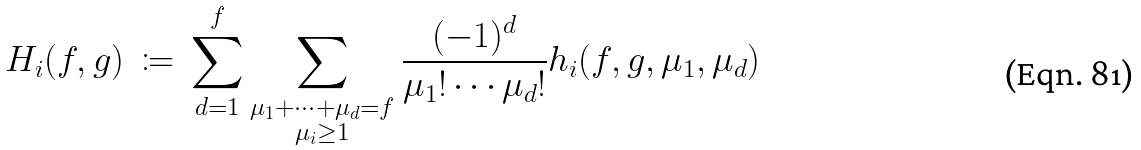<formula> <loc_0><loc_0><loc_500><loc_500>H _ { i } ( f , g ) \ \coloneqq \ \sum _ { d = 1 } ^ { f } \sum _ { \substack { \mu _ { 1 } + \dots + \mu _ { d } = f \\ \mu _ { i } \geq 1 } } \frac { ( - 1 ) ^ { d } } { \mu _ { 1 } ! \cdots \mu _ { d } ! } h _ { i } ( f , g , \mu _ { 1 } , \mu _ { d } )</formula> 